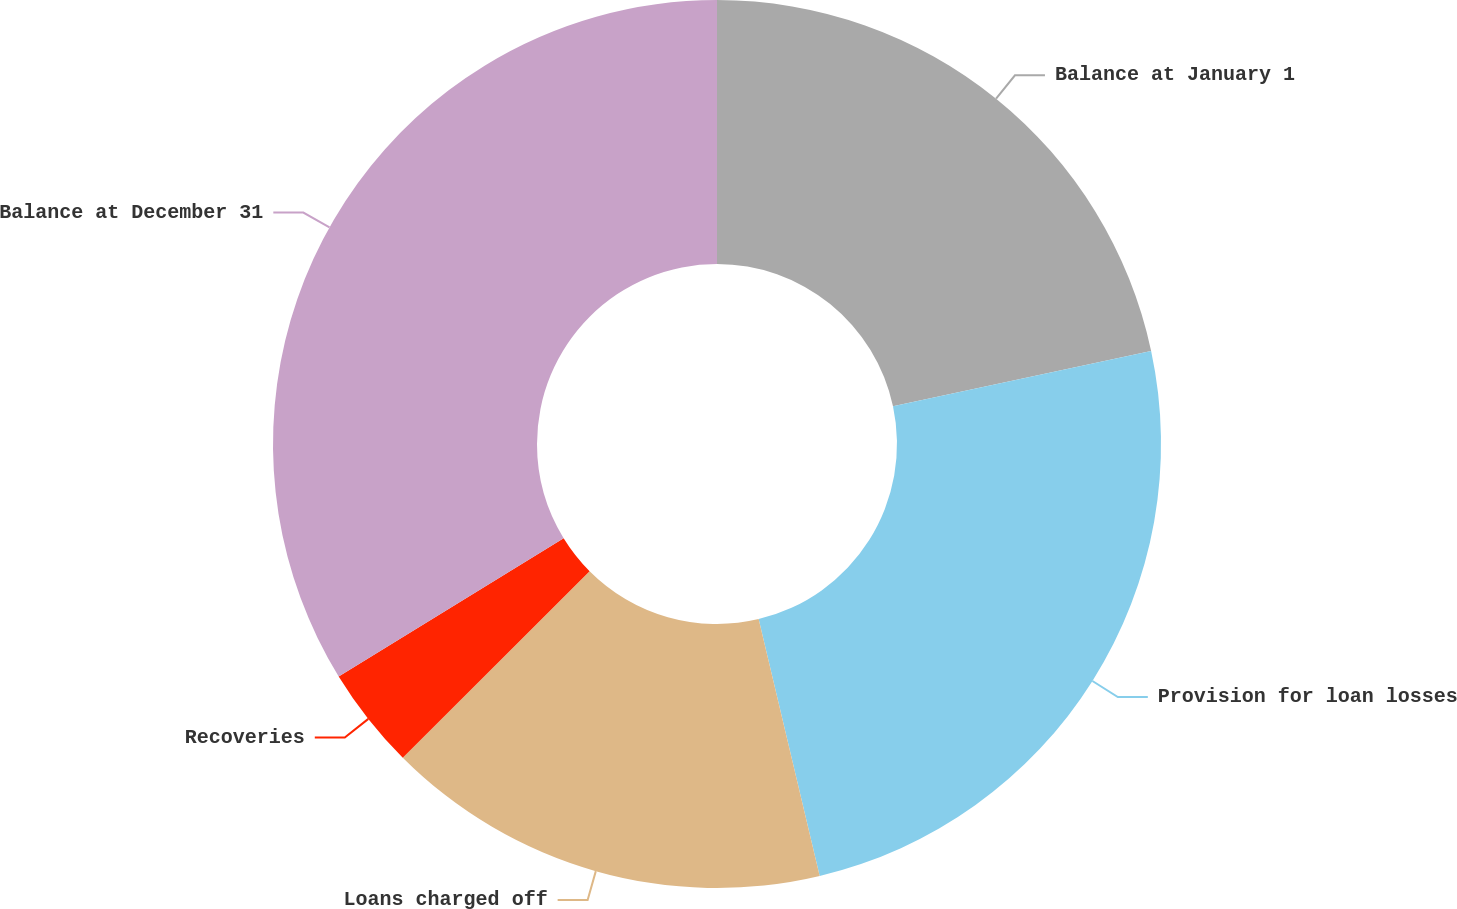Convert chart. <chart><loc_0><loc_0><loc_500><loc_500><pie_chart><fcel>Balance at January 1<fcel>Provision for loan losses<fcel>Loans charged off<fcel>Recoveries<fcel>Balance at December 31<nl><fcel>21.64%<fcel>24.65%<fcel>16.23%<fcel>3.72%<fcel>33.77%<nl></chart> 